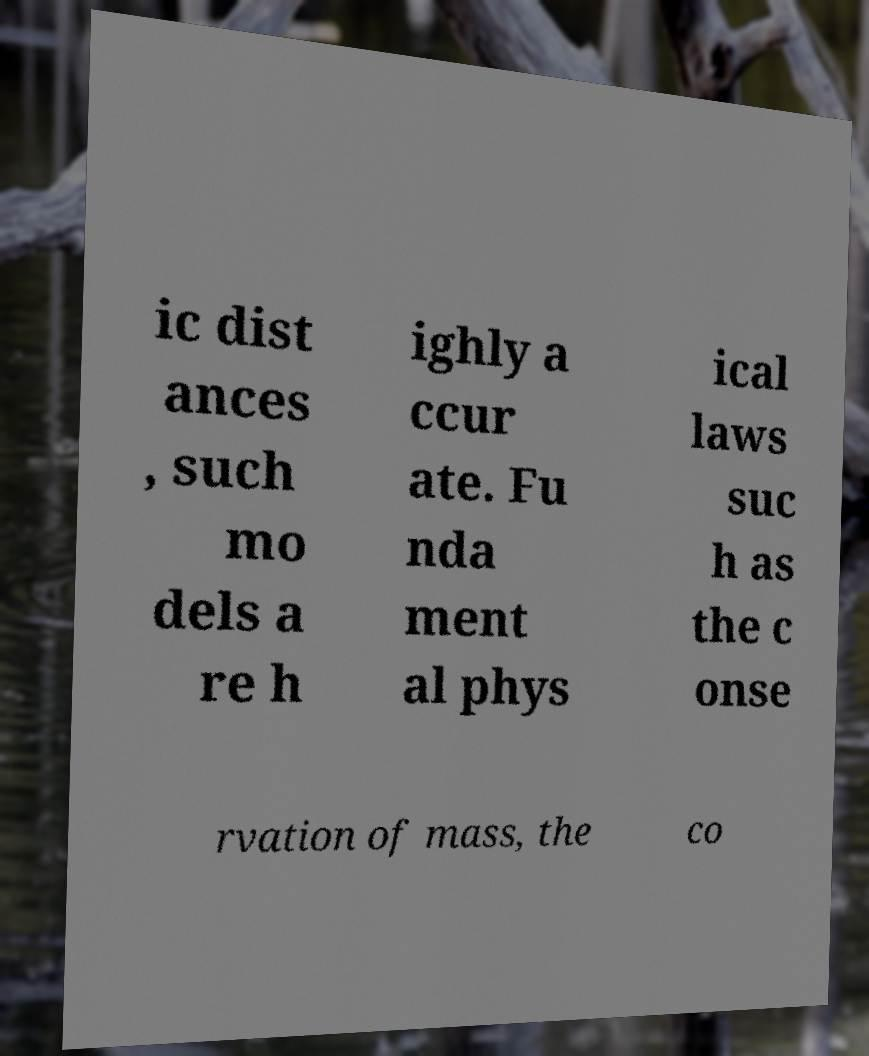What messages or text are displayed in this image? I need them in a readable, typed format. ic dist ances , such mo dels a re h ighly a ccur ate. Fu nda ment al phys ical laws suc h as the c onse rvation of mass, the co 